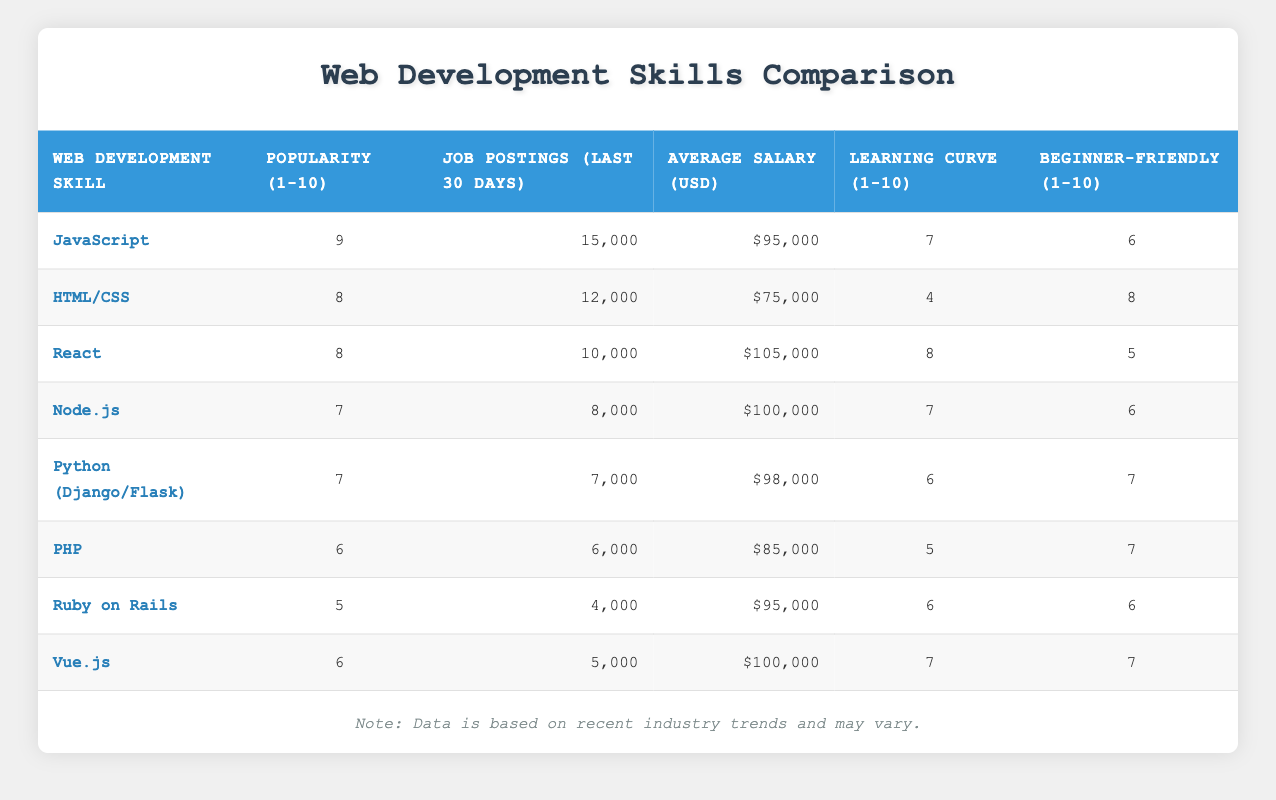What is the average salary for JavaScript developers? The table shows that the average salary for JavaScript developers is listed under the "Average Salary (USD)" column, which states $95,000.
Answer: $95,000 How many job postings were there for React in the last 30 days? The number of job postings for React is directly indicated in the "Job Postings (last 30 days)" column, which shows 10,000 postings.
Answer: 10,000 What is the total number of job postings for JavaScript and Node.js combined? The job postings for JavaScript are 15,000 and for Node.js are 8,000. By adding both values together, 15,000 + 8,000 equals 23,000.
Answer: 23,000 Is HTML/CSS considered beginner-friendly? HTML/CSS has a score of 8 in the "Beginner-Friendly (1-10)" column, indicating it is indeed considered beginner-friendly.
Answer: Yes Which skill has the highest average salary among the listed web development skills? By comparing the "Average Salary (USD)" column, React ($105,000) has the highest average salary, followed by Node.js ($100,000). React is the top skill.
Answer: React How does the learning curve for Python (Django/Flask) compare to that of Vue.js? Python (Django/Flask) has a learning curve score of 6, while Vue.js has a score of 7. This means Vue.js has a slightly steeper learning curve than Python (Django/Flask).
Answer: Vue.js has a steeper learning curve What is the median popularity score of the web development skills listed? To find the median popularity, we need to sort the popularity scores: 5, 6, 6, 7, 7, 8, 8, 9. Since there are 8 scores, the median will be the average of the 4th and 5th scores: (7 + 7) / 2 = 7.
Answer: 7 Is there a skill with a higher number of job postings than JavaScript? JavaScript has 15,000 job postings; none of the other skills have more, as the next highest is HTML/CSS with 12,000.
Answer: No Which web development skill is the least popular and has a job advertisement below 5,000? Ruby on Rails is the least popular with a score of 5 and has 4,000 job postings, which is below 5,000.
Answer: Ruby on Rails 